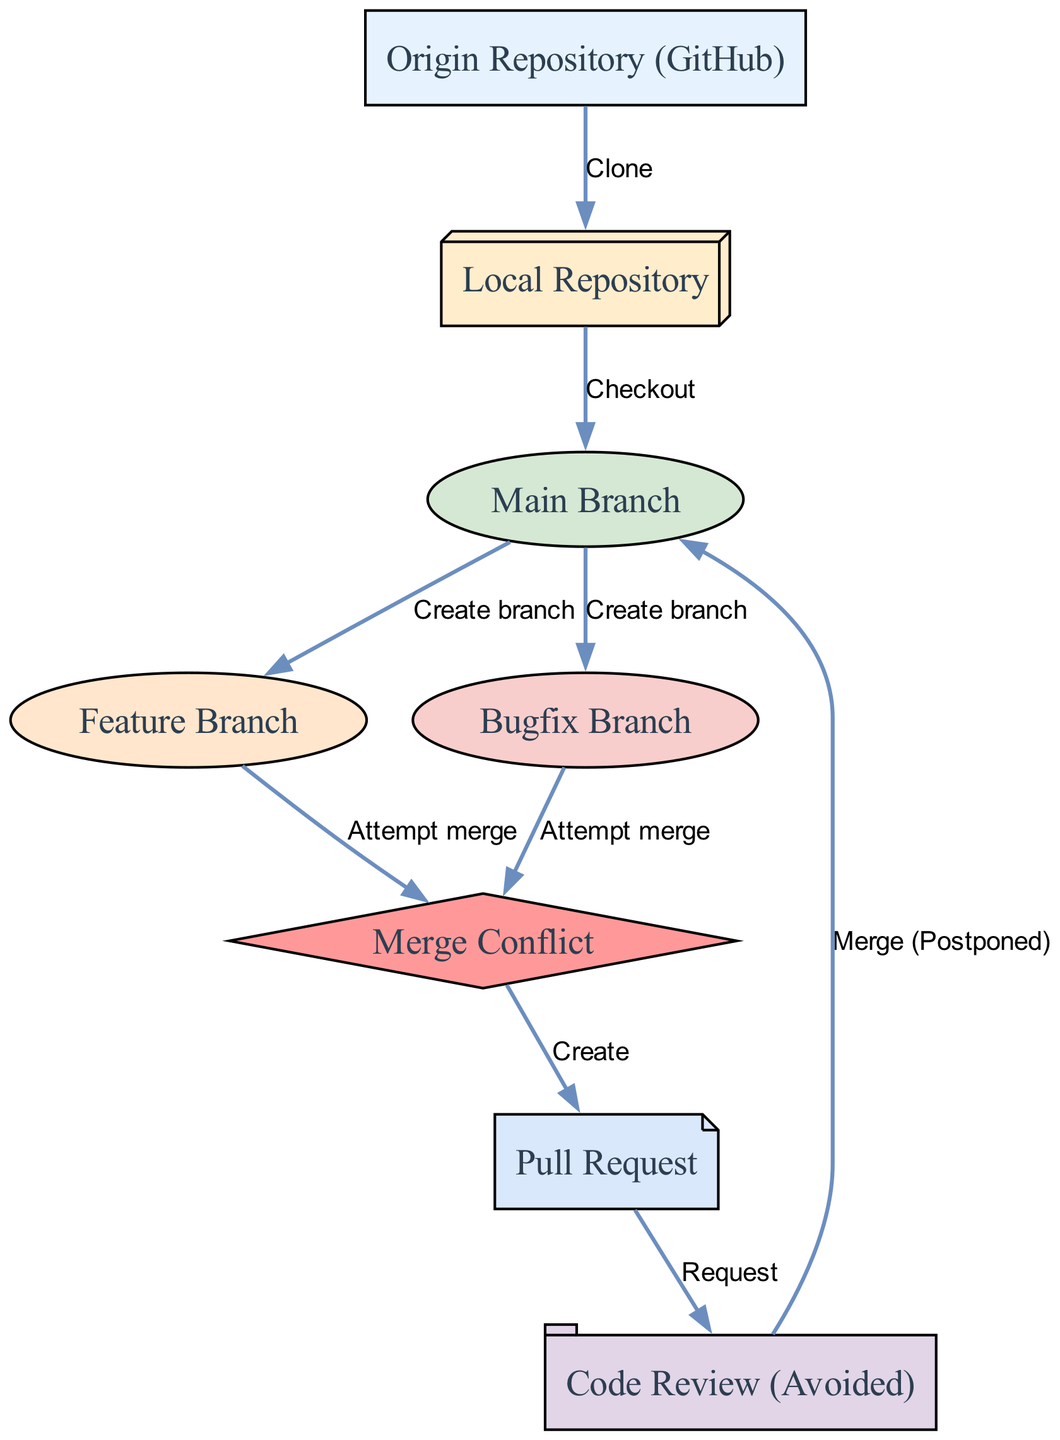What's the total number of nodes in the diagram? There are 8 nodes represented in the diagram, which include Origin Repository, Local Repository, Main Branch, Feature Branch, Bugfix Branch, Merge Conflict, Pull Request, and Code Review.
Answer: 8 How many edges connect the Local Repository to other nodes? The Local Repository has 2 outgoing edges: one to the Main Branch (Checkout) and another to the Origin Repository (Clone). Thus, it connects to 2 nodes.
Answer: 2 What type of node is Merge Conflict classified as? The Merge Conflict node is represented by a diamond shape in the diagram, indicating that it signifies a decision point or conflict in the workflow.
Answer: Diamond Which branch is created from the Main Branch in the diagram? The diagram shows that both the Feature Branch and Bugfix Branch are created from the Main Branch, indicating multiple development paths stemming from the primary codebase.
Answer: Feature Branch and Bugfix Branch What action leads to a Pull Request? The creation of a Merge Conflict results in the need to create a Pull Request, which is depicted as an edge leading to the Pull Request node from the Merge Conflict node.
Answer: Create How many attempts to merge lead to conflicts? There are 2 attempts to merge that lead to conflicts, one coming from the Feature Branch and another from the Bugfix Branch.
Answer: 2 What label describes the final action regarding the Code Review? The Code Review is labeled as "Avoided", implying that the Code Review process is not completed or addressed in the workflow diagram.
Answer: Avoided Which node represents the origin of the repository? The Origin Repository is specifically labeled in the diagram and depicted as a cloud shape, indicating it is the central source of code.
Answer: Origin Repository What is the last action linked to the Pull Request before the Code Review? The last action linked to the Pull Request is a request initiated for the Code Review, indicating the workflow process flow from creating a Pull Request to the Code Review phase.
Answer: Request 